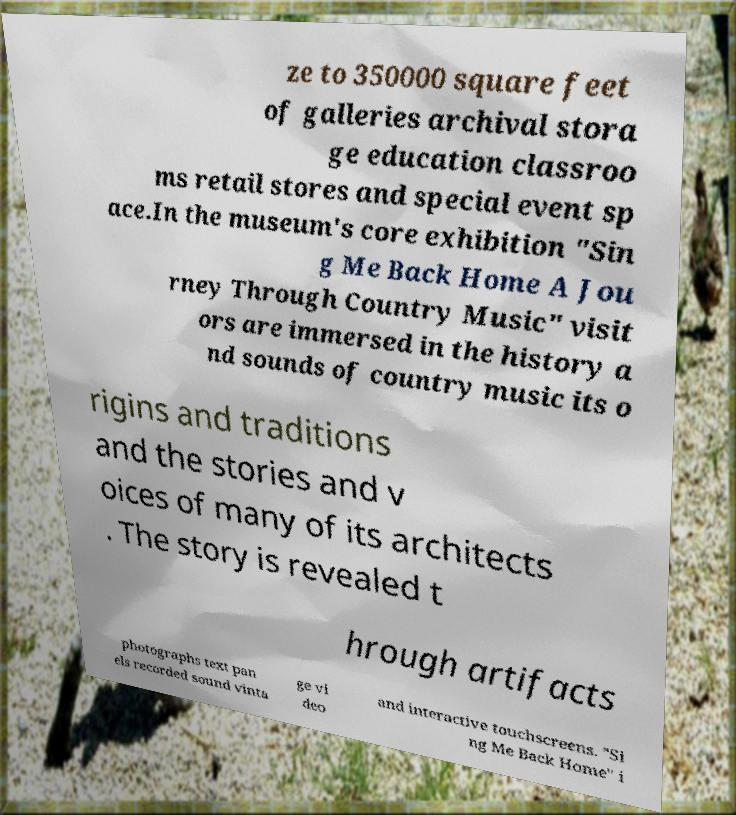There's text embedded in this image that I need extracted. Can you transcribe it verbatim? ze to 350000 square feet of galleries archival stora ge education classroo ms retail stores and special event sp ace.In the museum's core exhibition "Sin g Me Back Home A Jou rney Through Country Music" visit ors are immersed in the history a nd sounds of country music its o rigins and traditions and the stories and v oices of many of its architects . The story is revealed t hrough artifacts photographs text pan els recorded sound vinta ge vi deo and interactive touchscreens. "Si ng Me Back Home" i 